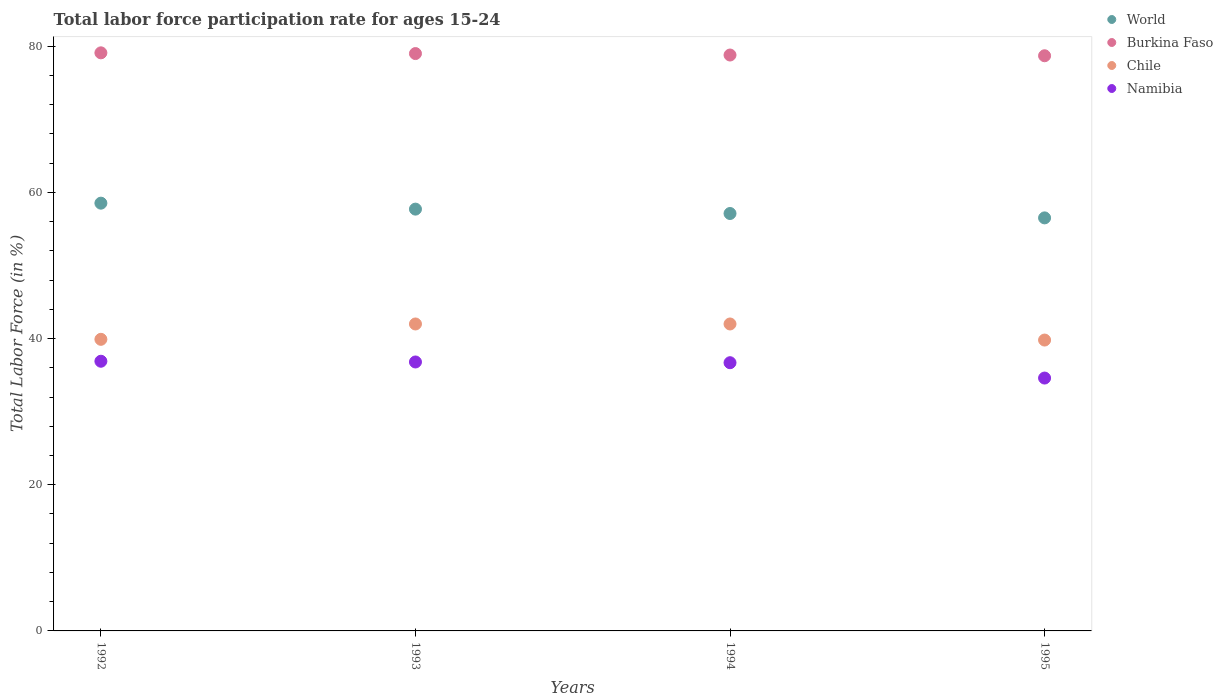What is the labor force participation rate in Namibia in 1994?
Make the answer very short. 36.7. Across all years, what is the maximum labor force participation rate in World?
Provide a succinct answer. 58.53. Across all years, what is the minimum labor force participation rate in Namibia?
Provide a short and direct response. 34.6. In which year was the labor force participation rate in World maximum?
Your response must be concise. 1992. What is the total labor force participation rate in Namibia in the graph?
Ensure brevity in your answer.  145. What is the difference between the labor force participation rate in Chile in 1992 and that in 1994?
Keep it short and to the point. -2.1. What is the difference between the labor force participation rate in Burkina Faso in 1993 and the labor force participation rate in Chile in 1992?
Your answer should be very brief. 39.1. What is the average labor force participation rate in Namibia per year?
Your answer should be very brief. 36.25. In the year 1993, what is the difference between the labor force participation rate in World and labor force participation rate in Chile?
Your response must be concise. 15.71. In how many years, is the labor force participation rate in Chile greater than 16 %?
Provide a succinct answer. 4. What is the ratio of the labor force participation rate in World in 1992 to that in 1994?
Make the answer very short. 1.02. Is the difference between the labor force participation rate in World in 1992 and 1995 greater than the difference between the labor force participation rate in Chile in 1992 and 1995?
Give a very brief answer. Yes. What is the difference between the highest and the lowest labor force participation rate in World?
Make the answer very short. 2.01. Is it the case that in every year, the sum of the labor force participation rate in Burkina Faso and labor force participation rate in World  is greater than the sum of labor force participation rate in Namibia and labor force participation rate in Chile?
Offer a terse response. Yes. Is the labor force participation rate in Burkina Faso strictly less than the labor force participation rate in Namibia over the years?
Keep it short and to the point. No. What is the difference between two consecutive major ticks on the Y-axis?
Your answer should be very brief. 20. Are the values on the major ticks of Y-axis written in scientific E-notation?
Ensure brevity in your answer.  No. Where does the legend appear in the graph?
Your answer should be very brief. Top right. How are the legend labels stacked?
Keep it short and to the point. Vertical. What is the title of the graph?
Make the answer very short. Total labor force participation rate for ages 15-24. What is the label or title of the X-axis?
Offer a terse response. Years. What is the Total Labor Force (in %) in World in 1992?
Your response must be concise. 58.53. What is the Total Labor Force (in %) of Burkina Faso in 1992?
Ensure brevity in your answer.  79.1. What is the Total Labor Force (in %) of Chile in 1992?
Offer a very short reply. 39.9. What is the Total Labor Force (in %) in Namibia in 1992?
Keep it short and to the point. 36.9. What is the Total Labor Force (in %) in World in 1993?
Keep it short and to the point. 57.71. What is the Total Labor Force (in %) in Burkina Faso in 1993?
Make the answer very short. 79. What is the Total Labor Force (in %) of Chile in 1993?
Keep it short and to the point. 42. What is the Total Labor Force (in %) in Namibia in 1993?
Give a very brief answer. 36.8. What is the Total Labor Force (in %) in World in 1994?
Make the answer very short. 57.12. What is the Total Labor Force (in %) in Burkina Faso in 1994?
Keep it short and to the point. 78.8. What is the Total Labor Force (in %) in Chile in 1994?
Your response must be concise. 42. What is the Total Labor Force (in %) in Namibia in 1994?
Provide a short and direct response. 36.7. What is the Total Labor Force (in %) in World in 1995?
Ensure brevity in your answer.  56.52. What is the Total Labor Force (in %) of Burkina Faso in 1995?
Ensure brevity in your answer.  78.7. What is the Total Labor Force (in %) in Chile in 1995?
Ensure brevity in your answer.  39.8. What is the Total Labor Force (in %) in Namibia in 1995?
Your answer should be compact. 34.6. Across all years, what is the maximum Total Labor Force (in %) of World?
Give a very brief answer. 58.53. Across all years, what is the maximum Total Labor Force (in %) in Burkina Faso?
Ensure brevity in your answer.  79.1. Across all years, what is the maximum Total Labor Force (in %) in Chile?
Provide a succinct answer. 42. Across all years, what is the maximum Total Labor Force (in %) of Namibia?
Your answer should be compact. 36.9. Across all years, what is the minimum Total Labor Force (in %) in World?
Provide a short and direct response. 56.52. Across all years, what is the minimum Total Labor Force (in %) of Burkina Faso?
Your answer should be very brief. 78.7. Across all years, what is the minimum Total Labor Force (in %) in Chile?
Give a very brief answer. 39.8. Across all years, what is the minimum Total Labor Force (in %) of Namibia?
Provide a succinct answer. 34.6. What is the total Total Labor Force (in %) in World in the graph?
Your answer should be compact. 229.88. What is the total Total Labor Force (in %) of Burkina Faso in the graph?
Offer a terse response. 315.6. What is the total Total Labor Force (in %) in Chile in the graph?
Your answer should be very brief. 163.7. What is the total Total Labor Force (in %) in Namibia in the graph?
Provide a succinct answer. 145. What is the difference between the Total Labor Force (in %) of World in 1992 and that in 1993?
Provide a short and direct response. 0.82. What is the difference between the Total Labor Force (in %) in World in 1992 and that in 1994?
Your answer should be very brief. 1.41. What is the difference between the Total Labor Force (in %) in Burkina Faso in 1992 and that in 1994?
Your answer should be very brief. 0.3. What is the difference between the Total Labor Force (in %) in Chile in 1992 and that in 1994?
Give a very brief answer. -2.1. What is the difference between the Total Labor Force (in %) in Namibia in 1992 and that in 1994?
Make the answer very short. 0.2. What is the difference between the Total Labor Force (in %) of World in 1992 and that in 1995?
Offer a very short reply. 2.01. What is the difference between the Total Labor Force (in %) of Namibia in 1992 and that in 1995?
Keep it short and to the point. 2.3. What is the difference between the Total Labor Force (in %) of World in 1993 and that in 1994?
Your answer should be compact. 0.6. What is the difference between the Total Labor Force (in %) of Burkina Faso in 1993 and that in 1994?
Provide a succinct answer. 0.2. What is the difference between the Total Labor Force (in %) in Chile in 1993 and that in 1994?
Give a very brief answer. 0. What is the difference between the Total Labor Force (in %) of Namibia in 1993 and that in 1994?
Offer a very short reply. 0.1. What is the difference between the Total Labor Force (in %) in World in 1993 and that in 1995?
Offer a terse response. 1.2. What is the difference between the Total Labor Force (in %) of Burkina Faso in 1994 and that in 1995?
Ensure brevity in your answer.  0.1. What is the difference between the Total Labor Force (in %) in Chile in 1994 and that in 1995?
Provide a short and direct response. 2.2. What is the difference between the Total Labor Force (in %) of World in 1992 and the Total Labor Force (in %) of Burkina Faso in 1993?
Your answer should be compact. -20.47. What is the difference between the Total Labor Force (in %) of World in 1992 and the Total Labor Force (in %) of Chile in 1993?
Your response must be concise. 16.53. What is the difference between the Total Labor Force (in %) of World in 1992 and the Total Labor Force (in %) of Namibia in 1993?
Keep it short and to the point. 21.73. What is the difference between the Total Labor Force (in %) of Burkina Faso in 1992 and the Total Labor Force (in %) of Chile in 1993?
Offer a very short reply. 37.1. What is the difference between the Total Labor Force (in %) in Burkina Faso in 1992 and the Total Labor Force (in %) in Namibia in 1993?
Your answer should be very brief. 42.3. What is the difference between the Total Labor Force (in %) in World in 1992 and the Total Labor Force (in %) in Burkina Faso in 1994?
Your answer should be very brief. -20.27. What is the difference between the Total Labor Force (in %) of World in 1992 and the Total Labor Force (in %) of Chile in 1994?
Provide a succinct answer. 16.53. What is the difference between the Total Labor Force (in %) in World in 1992 and the Total Labor Force (in %) in Namibia in 1994?
Your answer should be very brief. 21.83. What is the difference between the Total Labor Force (in %) in Burkina Faso in 1992 and the Total Labor Force (in %) in Chile in 1994?
Offer a very short reply. 37.1. What is the difference between the Total Labor Force (in %) in Burkina Faso in 1992 and the Total Labor Force (in %) in Namibia in 1994?
Make the answer very short. 42.4. What is the difference between the Total Labor Force (in %) in Chile in 1992 and the Total Labor Force (in %) in Namibia in 1994?
Give a very brief answer. 3.2. What is the difference between the Total Labor Force (in %) of World in 1992 and the Total Labor Force (in %) of Burkina Faso in 1995?
Your response must be concise. -20.17. What is the difference between the Total Labor Force (in %) in World in 1992 and the Total Labor Force (in %) in Chile in 1995?
Your answer should be compact. 18.73. What is the difference between the Total Labor Force (in %) in World in 1992 and the Total Labor Force (in %) in Namibia in 1995?
Ensure brevity in your answer.  23.93. What is the difference between the Total Labor Force (in %) of Burkina Faso in 1992 and the Total Labor Force (in %) of Chile in 1995?
Your answer should be compact. 39.3. What is the difference between the Total Labor Force (in %) of Burkina Faso in 1992 and the Total Labor Force (in %) of Namibia in 1995?
Provide a succinct answer. 44.5. What is the difference between the Total Labor Force (in %) of World in 1993 and the Total Labor Force (in %) of Burkina Faso in 1994?
Your answer should be very brief. -21.09. What is the difference between the Total Labor Force (in %) in World in 1993 and the Total Labor Force (in %) in Chile in 1994?
Offer a terse response. 15.71. What is the difference between the Total Labor Force (in %) of World in 1993 and the Total Labor Force (in %) of Namibia in 1994?
Offer a very short reply. 21.01. What is the difference between the Total Labor Force (in %) in Burkina Faso in 1993 and the Total Labor Force (in %) in Namibia in 1994?
Your answer should be very brief. 42.3. What is the difference between the Total Labor Force (in %) in World in 1993 and the Total Labor Force (in %) in Burkina Faso in 1995?
Your answer should be very brief. -20.99. What is the difference between the Total Labor Force (in %) in World in 1993 and the Total Labor Force (in %) in Chile in 1995?
Offer a terse response. 17.91. What is the difference between the Total Labor Force (in %) in World in 1993 and the Total Labor Force (in %) in Namibia in 1995?
Offer a very short reply. 23.11. What is the difference between the Total Labor Force (in %) of Burkina Faso in 1993 and the Total Labor Force (in %) of Chile in 1995?
Make the answer very short. 39.2. What is the difference between the Total Labor Force (in %) of Burkina Faso in 1993 and the Total Labor Force (in %) of Namibia in 1995?
Keep it short and to the point. 44.4. What is the difference between the Total Labor Force (in %) in Chile in 1993 and the Total Labor Force (in %) in Namibia in 1995?
Make the answer very short. 7.4. What is the difference between the Total Labor Force (in %) of World in 1994 and the Total Labor Force (in %) of Burkina Faso in 1995?
Offer a very short reply. -21.58. What is the difference between the Total Labor Force (in %) in World in 1994 and the Total Labor Force (in %) in Chile in 1995?
Your answer should be very brief. 17.32. What is the difference between the Total Labor Force (in %) of World in 1994 and the Total Labor Force (in %) of Namibia in 1995?
Your response must be concise. 22.52. What is the difference between the Total Labor Force (in %) in Burkina Faso in 1994 and the Total Labor Force (in %) in Chile in 1995?
Make the answer very short. 39. What is the difference between the Total Labor Force (in %) of Burkina Faso in 1994 and the Total Labor Force (in %) of Namibia in 1995?
Your answer should be very brief. 44.2. What is the difference between the Total Labor Force (in %) of Chile in 1994 and the Total Labor Force (in %) of Namibia in 1995?
Your answer should be very brief. 7.4. What is the average Total Labor Force (in %) in World per year?
Provide a short and direct response. 57.47. What is the average Total Labor Force (in %) in Burkina Faso per year?
Provide a short and direct response. 78.9. What is the average Total Labor Force (in %) of Chile per year?
Your answer should be compact. 40.92. What is the average Total Labor Force (in %) in Namibia per year?
Keep it short and to the point. 36.25. In the year 1992, what is the difference between the Total Labor Force (in %) of World and Total Labor Force (in %) of Burkina Faso?
Provide a short and direct response. -20.57. In the year 1992, what is the difference between the Total Labor Force (in %) of World and Total Labor Force (in %) of Chile?
Ensure brevity in your answer.  18.63. In the year 1992, what is the difference between the Total Labor Force (in %) of World and Total Labor Force (in %) of Namibia?
Your answer should be compact. 21.63. In the year 1992, what is the difference between the Total Labor Force (in %) in Burkina Faso and Total Labor Force (in %) in Chile?
Provide a succinct answer. 39.2. In the year 1992, what is the difference between the Total Labor Force (in %) in Burkina Faso and Total Labor Force (in %) in Namibia?
Your response must be concise. 42.2. In the year 1993, what is the difference between the Total Labor Force (in %) in World and Total Labor Force (in %) in Burkina Faso?
Offer a terse response. -21.29. In the year 1993, what is the difference between the Total Labor Force (in %) of World and Total Labor Force (in %) of Chile?
Ensure brevity in your answer.  15.71. In the year 1993, what is the difference between the Total Labor Force (in %) in World and Total Labor Force (in %) in Namibia?
Make the answer very short. 20.91. In the year 1993, what is the difference between the Total Labor Force (in %) of Burkina Faso and Total Labor Force (in %) of Chile?
Provide a succinct answer. 37. In the year 1993, what is the difference between the Total Labor Force (in %) of Burkina Faso and Total Labor Force (in %) of Namibia?
Your answer should be very brief. 42.2. In the year 1994, what is the difference between the Total Labor Force (in %) of World and Total Labor Force (in %) of Burkina Faso?
Ensure brevity in your answer.  -21.68. In the year 1994, what is the difference between the Total Labor Force (in %) in World and Total Labor Force (in %) in Chile?
Your answer should be compact. 15.12. In the year 1994, what is the difference between the Total Labor Force (in %) in World and Total Labor Force (in %) in Namibia?
Your response must be concise. 20.42. In the year 1994, what is the difference between the Total Labor Force (in %) in Burkina Faso and Total Labor Force (in %) in Chile?
Provide a succinct answer. 36.8. In the year 1994, what is the difference between the Total Labor Force (in %) in Burkina Faso and Total Labor Force (in %) in Namibia?
Give a very brief answer. 42.1. In the year 1995, what is the difference between the Total Labor Force (in %) of World and Total Labor Force (in %) of Burkina Faso?
Provide a short and direct response. -22.18. In the year 1995, what is the difference between the Total Labor Force (in %) of World and Total Labor Force (in %) of Chile?
Your answer should be very brief. 16.72. In the year 1995, what is the difference between the Total Labor Force (in %) of World and Total Labor Force (in %) of Namibia?
Your answer should be very brief. 21.92. In the year 1995, what is the difference between the Total Labor Force (in %) in Burkina Faso and Total Labor Force (in %) in Chile?
Give a very brief answer. 38.9. In the year 1995, what is the difference between the Total Labor Force (in %) in Burkina Faso and Total Labor Force (in %) in Namibia?
Offer a very short reply. 44.1. In the year 1995, what is the difference between the Total Labor Force (in %) in Chile and Total Labor Force (in %) in Namibia?
Ensure brevity in your answer.  5.2. What is the ratio of the Total Labor Force (in %) in World in 1992 to that in 1993?
Keep it short and to the point. 1.01. What is the ratio of the Total Labor Force (in %) of Burkina Faso in 1992 to that in 1993?
Provide a short and direct response. 1. What is the ratio of the Total Labor Force (in %) of Chile in 1992 to that in 1993?
Offer a terse response. 0.95. What is the ratio of the Total Labor Force (in %) of World in 1992 to that in 1994?
Make the answer very short. 1.02. What is the ratio of the Total Labor Force (in %) in Burkina Faso in 1992 to that in 1994?
Ensure brevity in your answer.  1. What is the ratio of the Total Labor Force (in %) in Chile in 1992 to that in 1994?
Offer a terse response. 0.95. What is the ratio of the Total Labor Force (in %) of Namibia in 1992 to that in 1994?
Provide a short and direct response. 1.01. What is the ratio of the Total Labor Force (in %) in World in 1992 to that in 1995?
Your response must be concise. 1.04. What is the ratio of the Total Labor Force (in %) in Burkina Faso in 1992 to that in 1995?
Your answer should be compact. 1.01. What is the ratio of the Total Labor Force (in %) of Namibia in 1992 to that in 1995?
Keep it short and to the point. 1.07. What is the ratio of the Total Labor Force (in %) of World in 1993 to that in 1994?
Provide a short and direct response. 1.01. What is the ratio of the Total Labor Force (in %) in Burkina Faso in 1993 to that in 1994?
Provide a succinct answer. 1. What is the ratio of the Total Labor Force (in %) of Chile in 1993 to that in 1994?
Ensure brevity in your answer.  1. What is the ratio of the Total Labor Force (in %) in World in 1993 to that in 1995?
Offer a terse response. 1.02. What is the ratio of the Total Labor Force (in %) in Chile in 1993 to that in 1995?
Ensure brevity in your answer.  1.06. What is the ratio of the Total Labor Force (in %) in Namibia in 1993 to that in 1995?
Provide a succinct answer. 1.06. What is the ratio of the Total Labor Force (in %) in World in 1994 to that in 1995?
Keep it short and to the point. 1.01. What is the ratio of the Total Labor Force (in %) in Burkina Faso in 1994 to that in 1995?
Your response must be concise. 1. What is the ratio of the Total Labor Force (in %) in Chile in 1994 to that in 1995?
Make the answer very short. 1.06. What is the ratio of the Total Labor Force (in %) in Namibia in 1994 to that in 1995?
Keep it short and to the point. 1.06. What is the difference between the highest and the second highest Total Labor Force (in %) in World?
Your answer should be very brief. 0.82. What is the difference between the highest and the second highest Total Labor Force (in %) of Chile?
Your response must be concise. 0. What is the difference between the highest and the second highest Total Labor Force (in %) of Namibia?
Your response must be concise. 0.1. What is the difference between the highest and the lowest Total Labor Force (in %) in World?
Your answer should be very brief. 2.01. What is the difference between the highest and the lowest Total Labor Force (in %) in Burkina Faso?
Your response must be concise. 0.4. 